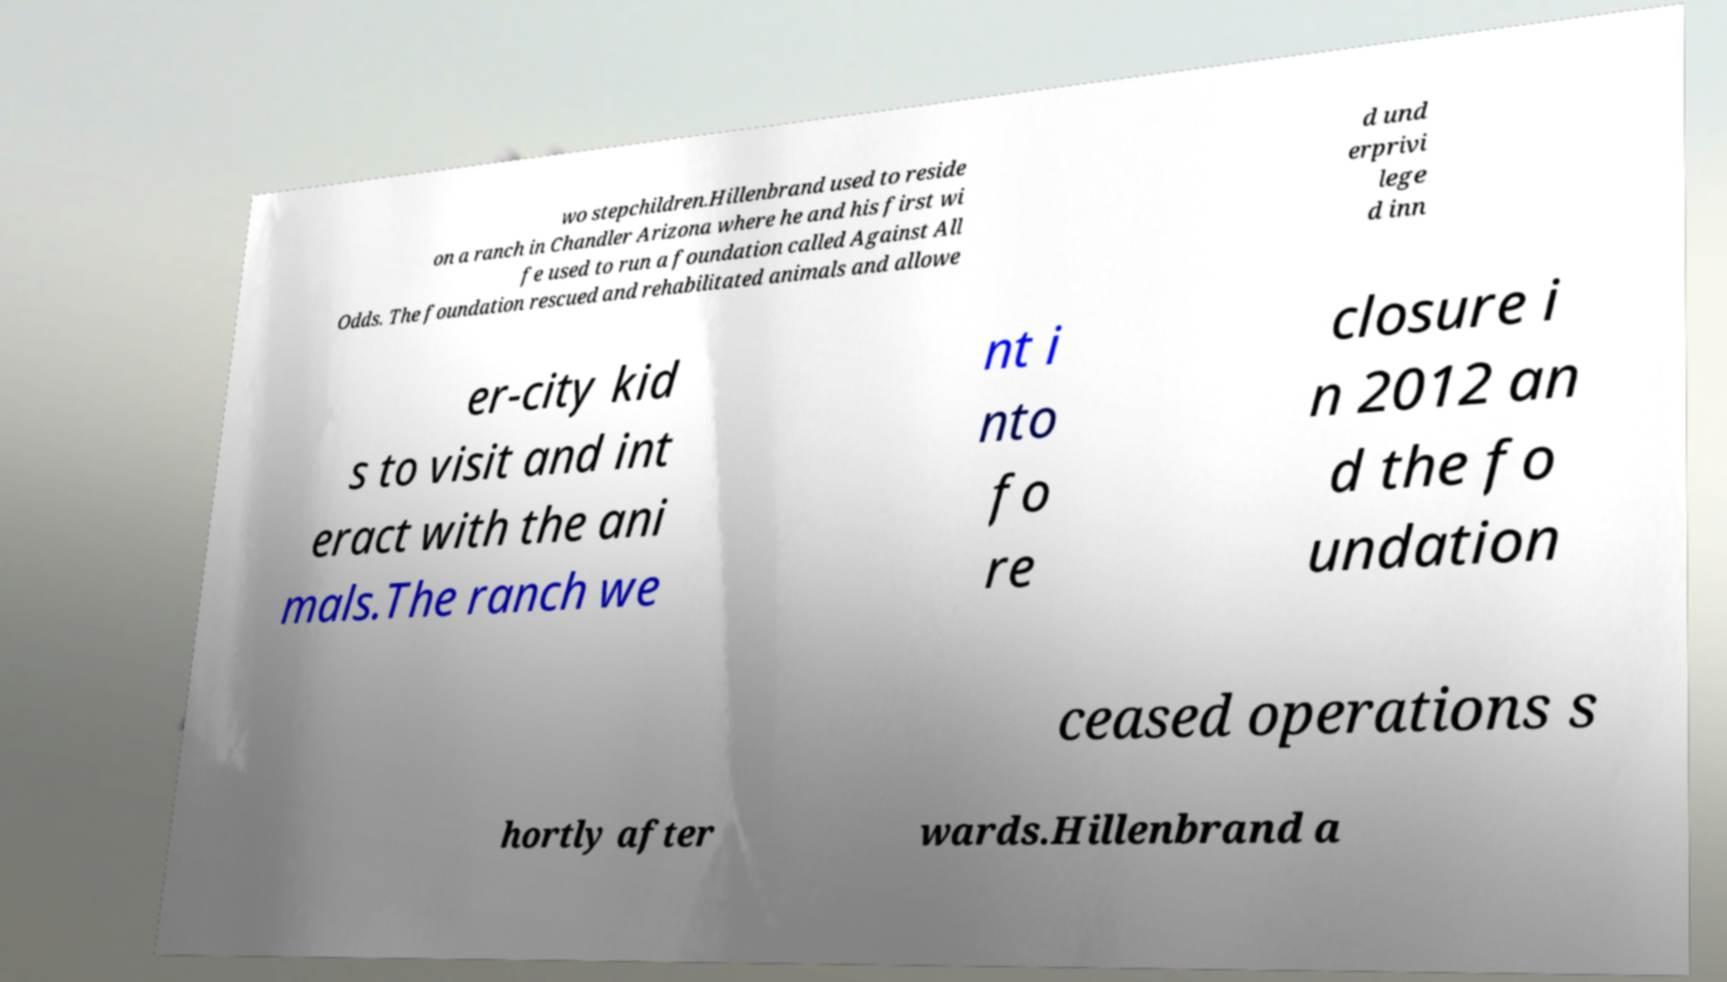Could you assist in decoding the text presented in this image and type it out clearly? wo stepchildren.Hillenbrand used to reside on a ranch in Chandler Arizona where he and his first wi fe used to run a foundation called Against All Odds. The foundation rescued and rehabilitated animals and allowe d und erprivi lege d inn er-city kid s to visit and int eract with the ani mals.The ranch we nt i nto fo re closure i n 2012 an d the fo undation ceased operations s hortly after wards.Hillenbrand a 